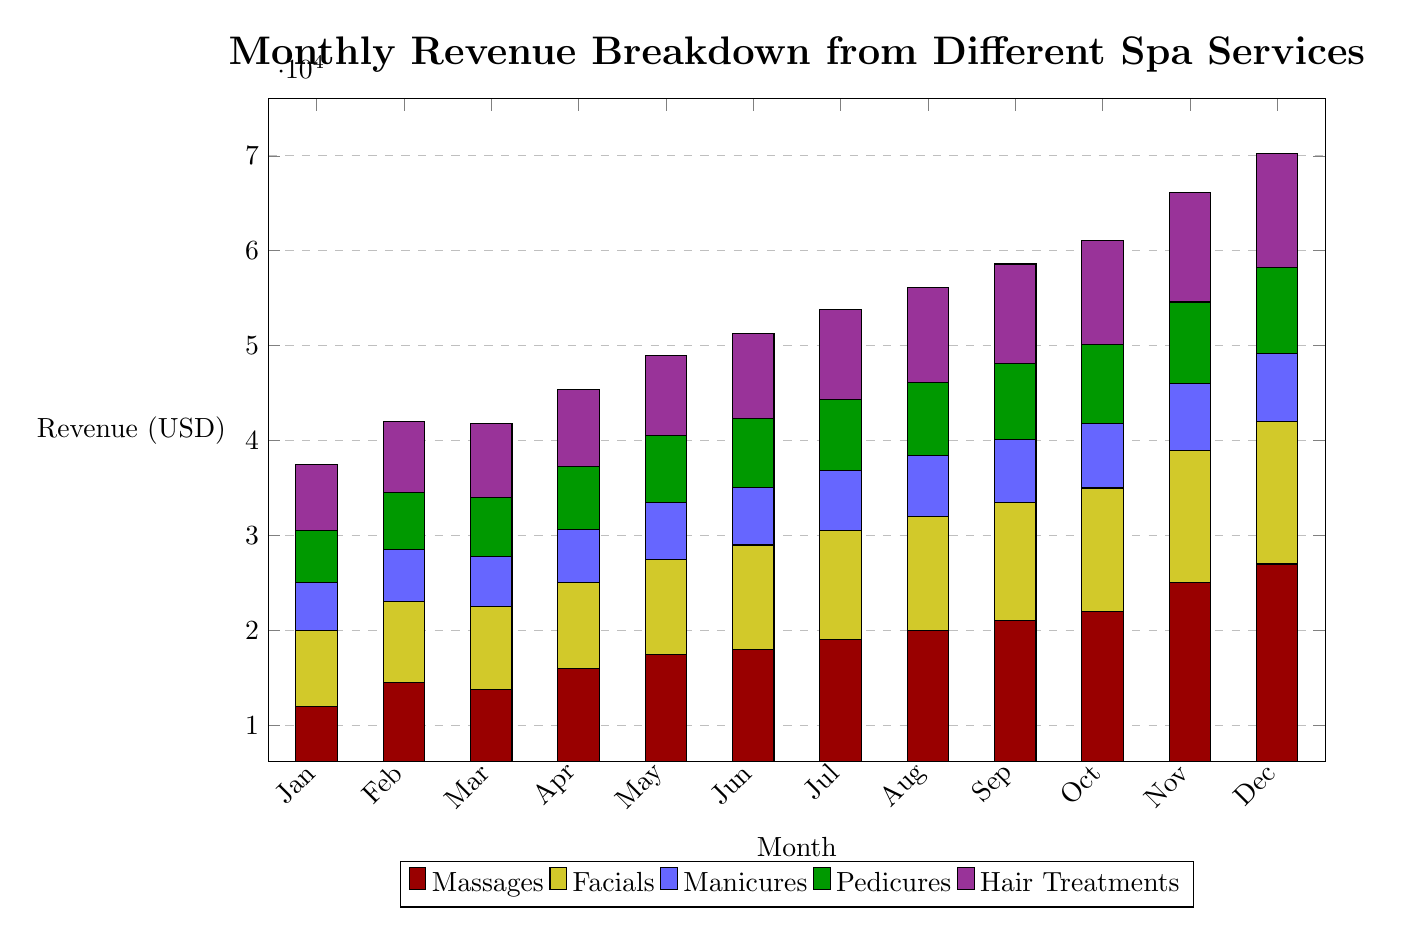What is the total revenue for December? By observing the stacked bar for December, I can add the revenues for each service: Massages (27000) + Facials (15000) + Manicures (7200) + Pedicures (9000) + Hair Treatments (12000). Summing these gives 27000 + 15000 + 7200 + 9000 + 12000 = 76200.
Answer: 76200 Which month has the highest revenue from Hair Treatments? Looking at the blue segment for Hair Treatments, I can see that the highest revenue is in December, where it reaches 12000.
Answer: 12000 How much revenue does Facials generate in January? The yellow segment representing Facials in January shows a revenue of 8000.
Answer: 8000 What is the second-highest revenue month for Massages? Analyzing the red segment for Massages, the months are: Jan (12000), Feb (14500), Mar (13800), Apr (16000), May (17500), Jun (18000), Jul (19000), Aug (20000), Sep (21000), Oct (22000), Nov (25000), Dec (27000). The second-highest value is November with 25000.
Answer: 25000 Which service generated the lowest revenue in June? In June, the revenues are as follows: Massages (18000), Facials (11000), Manicures (6100), Pedicures (7200), and Hair Treatments (9000). Manicures, with a revenue of 6100, is the lowest.
Answer: Manicures What is the total revenue for all services in October? For October, the revenues for each service are: Massages (22000), Facials (13000), Manicures (6800), Pedicures (8300), and Hair Treatments (11000). Adding these up gives: 22000 + 13000 + 6800 + 8300 + 11000 = 63600.
Answer: 63600 In which month do Pedicures first exceed 7000 in revenue? Observing the green segment of Pedicures, I note that it surpasses 7000 for the first time in May, where the revenue is 7000.
Answer: May What is the cumulative revenue from all services in March? In March, the revenue for each service is: Massages (13800), Facials (8700), Manicures (5300), Pedicures (6200), and Hair Treatments (7800). Adding all these gives: 13800 + 8700 + 5300 + 6200 + 7800 = 42000.
Answer: 42000 Which service shows a consistent increase in revenue every month? By examining the segments closely, I can see that Massages show a consistent increase for each month from January (12000) to December (27000), confirming it shows growth every month.
Answer: Massages 